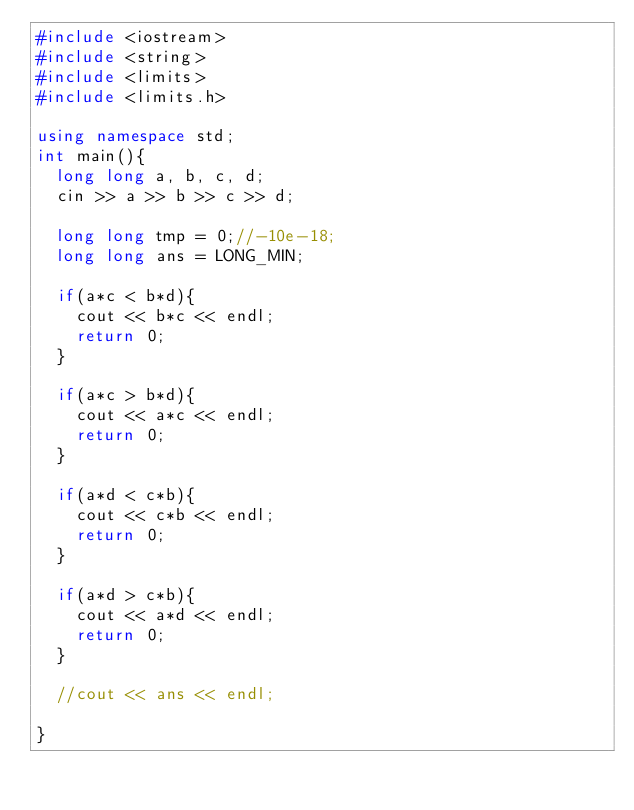Convert code to text. <code><loc_0><loc_0><loc_500><loc_500><_C++_>#include <iostream>
#include <string>
#include <limits>
#include <limits.h>

using namespace std;
int main(){
  long long a, b, c, d;
  cin >> a >> b >> c >> d;

  long long tmp = 0;//-10e-18;
  long long ans = LONG_MIN;

  if(a*c < b*d){
    cout << b*c << endl;
    return 0;
  }
  
  if(a*c > b*d){
    cout << a*c << endl;
    return 0;
  }

  if(a*d < c*b){
    cout << c*b << endl;
    return 0;
  }

  if(a*d > c*b){
    cout << a*d << endl;
    return 0;
  }

  //cout << ans << endl;

}</code> 